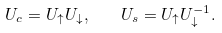Convert formula to latex. <formula><loc_0><loc_0><loc_500><loc_500>U _ { c } = U _ { \uparrow } U _ { \downarrow } , \quad U _ { s } = U _ { \uparrow } U ^ { - 1 } _ { \downarrow } .</formula> 